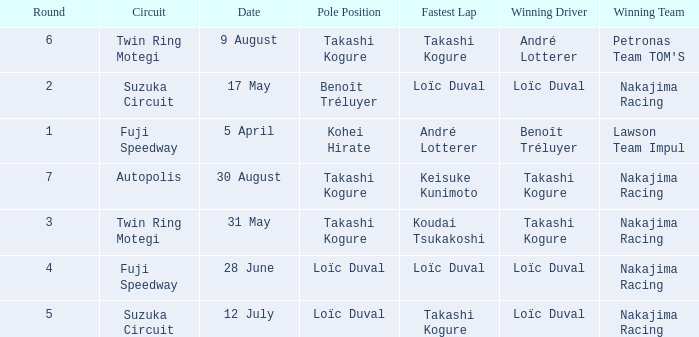How many drivers drove on Suzuka Circuit where Loïc Duval took pole position? 1.0. 